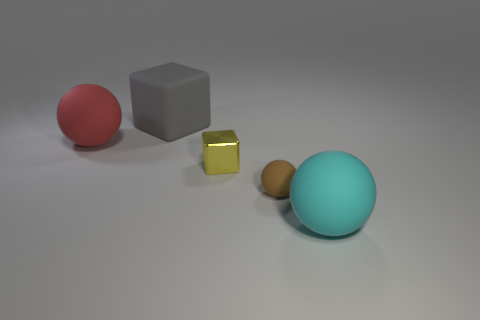Add 5 cyan rubber things. How many objects exist? 10 Subtract all blocks. How many objects are left? 3 Add 2 big brown metal blocks. How many big brown metal blocks exist? 2 Subtract 0 blue balls. How many objects are left? 5 Subtract all tiny yellow rubber cylinders. Subtract all big cyan spheres. How many objects are left? 4 Add 4 matte spheres. How many matte spheres are left? 7 